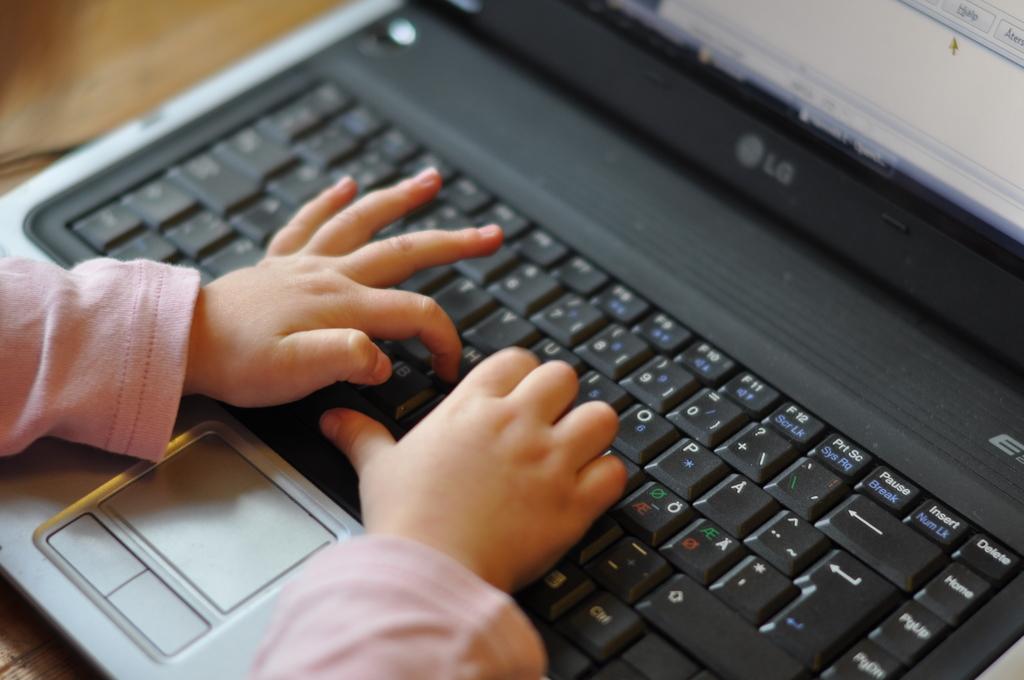What brand is the laptop?
Your answer should be very brief. Lg. What does the top right key say?
Make the answer very short. Delete. 